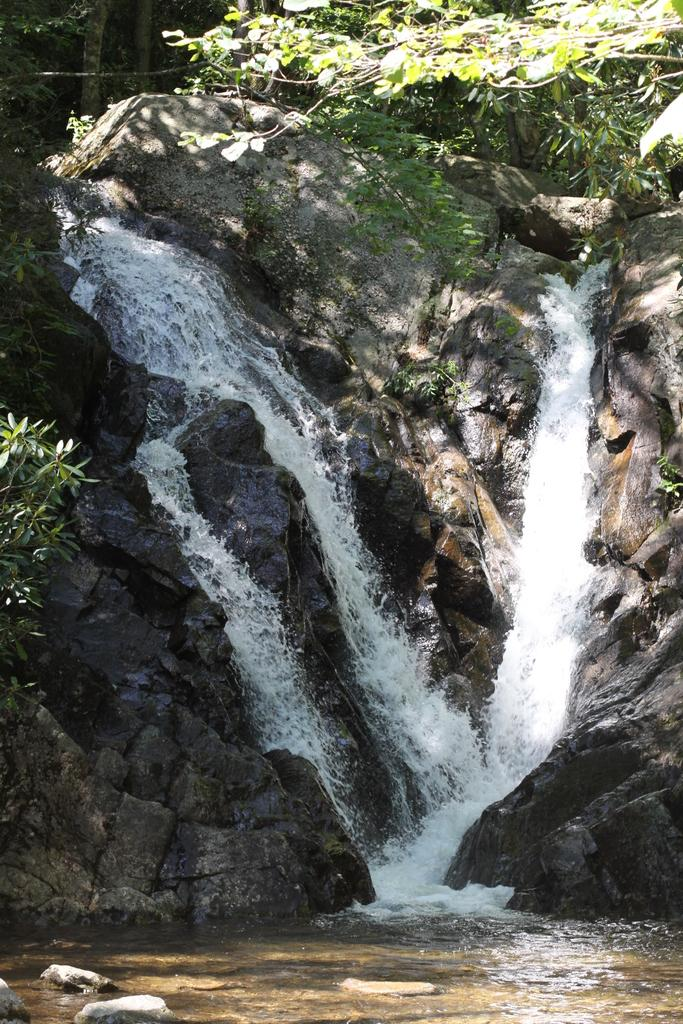What natural feature is the main subject of the image? There is a waterfall in the image. What type of vegetation can be seen in the image? There are trees in the image. What other geological features are present in the image? There are rocks in the image. Can you see the collar of the dog in the image? There is no dog or collar present in the image. What type of place is depicted in the image? The image does not depict a specific place; it features a waterfall, trees, and rocks. 